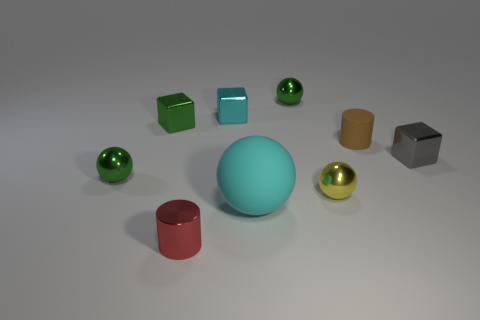What material is the tiny object that is the same color as the large object?
Give a very brief answer. Metal. What number of other objects are there of the same color as the big rubber ball?
Your response must be concise. 1. What number of blue objects are metallic blocks or rubber cylinders?
Offer a terse response. 0. What is the tiny green sphere on the right side of the big cyan object made of?
Provide a succinct answer. Metal. Do the cyan object that is left of the big ball and the gray thing have the same material?
Give a very brief answer. Yes. The tiny rubber thing has what shape?
Keep it short and to the point. Cylinder. How many spheres are in front of the green metallic thing in front of the tiny brown thing behind the red metallic cylinder?
Provide a succinct answer. 2. How many other things are there of the same material as the tiny cyan block?
Your response must be concise. 6. What is the material of the cyan block that is the same size as the gray object?
Offer a terse response. Metal. There is a rubber thing that is behind the yellow shiny object; is it the same color as the metallic block that is right of the brown thing?
Offer a very short reply. No. 